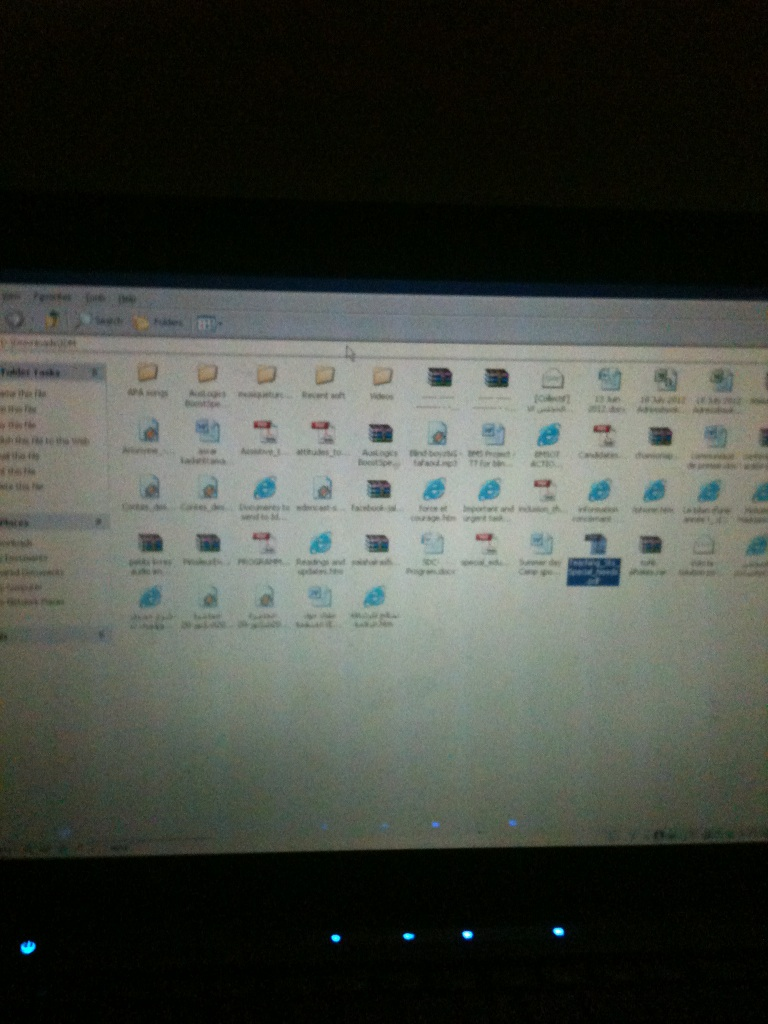Imagine you could interact with the files represented by those icons. What would you do? If I could interact with the files, I would start by categorizing and organizing them better. I’d place all related documents into subfolders to decrease clutter. Then, I would check the software-related icons to ensure they are updated versions, removing any outdated applications. Lastly, I’d clean up any redundant files and perform a backup of important documents. Why do you think organizing files is important? Organizing files is crucial for several reasons. It improves efficiency and productivity by making it easier to find needed files quickly, and it reduces the risk of losing important data. Well-organized files can also protect against accidental deletion and help in better management during data backups. Additionally, it creates a sense of order and can minimize the mental overload caused by cluttered digital spaces. 